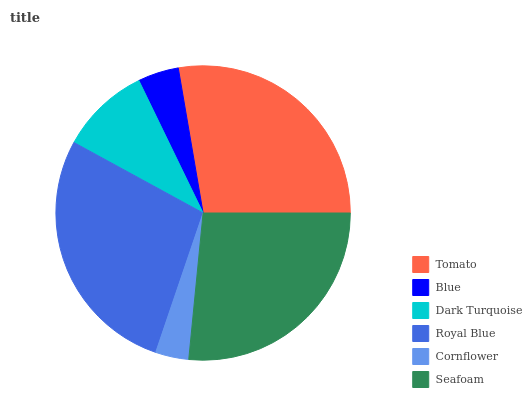Is Cornflower the minimum?
Answer yes or no. Yes. Is Royal Blue the maximum?
Answer yes or no. Yes. Is Blue the minimum?
Answer yes or no. No. Is Blue the maximum?
Answer yes or no. No. Is Tomato greater than Blue?
Answer yes or no. Yes. Is Blue less than Tomato?
Answer yes or no. Yes. Is Blue greater than Tomato?
Answer yes or no. No. Is Tomato less than Blue?
Answer yes or no. No. Is Seafoam the high median?
Answer yes or no. Yes. Is Dark Turquoise the low median?
Answer yes or no. Yes. Is Dark Turquoise the high median?
Answer yes or no. No. Is Cornflower the low median?
Answer yes or no. No. 